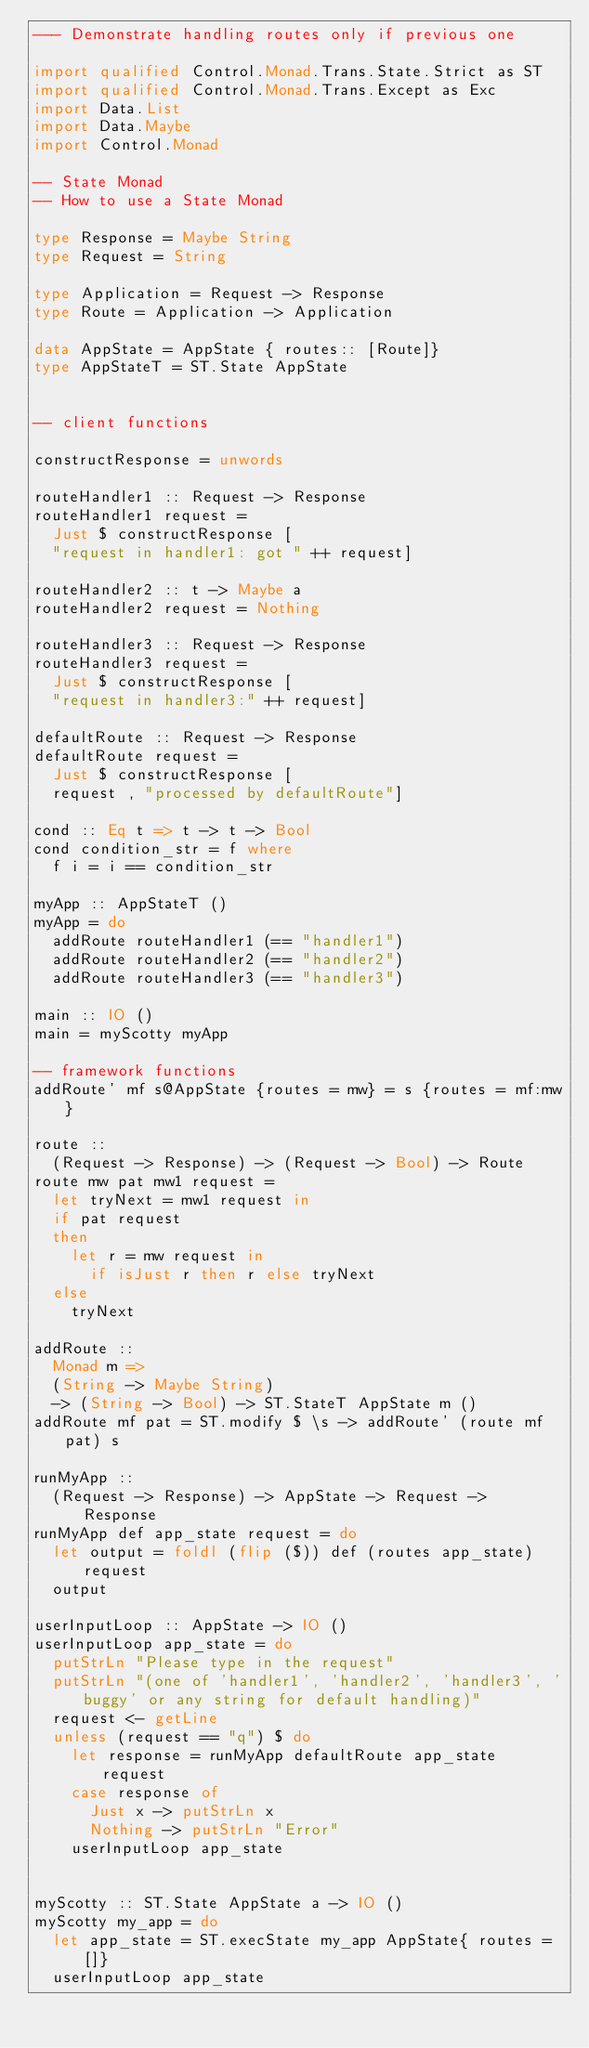<code> <loc_0><loc_0><loc_500><loc_500><_Haskell_>--- Demonstrate handling routes only if previous one

import qualified Control.Monad.Trans.State.Strict as ST
import qualified Control.Monad.Trans.Except as Exc
import Data.List
import Data.Maybe
import Control.Monad

-- State Monad
-- How to use a State Monad

type Response = Maybe String
type Request = String

type Application = Request -> Response
type Route = Application -> Application

data AppState = AppState { routes:: [Route]}
type AppStateT = ST.State AppState


-- client functions

constructResponse = unwords

routeHandler1 :: Request -> Response
routeHandler1 request =
  Just $ constructResponse [
  "request in handler1: got " ++ request]

routeHandler2 :: t -> Maybe a
routeHandler2 request = Nothing

routeHandler3 :: Request -> Response
routeHandler3 request =
  Just $ constructResponse [
  "request in handler3:" ++ request]

defaultRoute :: Request -> Response
defaultRoute request =
  Just $ constructResponse [
  request , "processed by defaultRoute"]

cond :: Eq t => t -> t -> Bool
cond condition_str = f where
  f i = i == condition_str

myApp :: AppStateT ()
myApp = do
  addRoute routeHandler1 (== "handler1")
  addRoute routeHandler2 (== "handler2")
  addRoute routeHandler3 (== "handler3")

main :: IO ()
main = myScotty myApp

-- framework functions
addRoute' mf s@AppState {routes = mw} = s {routes = mf:mw}

route ::
  (Request -> Response) -> (Request -> Bool) -> Route
route mw pat mw1 request =
  let tryNext = mw1 request in
  if pat request
  then
    let r = mw request in
      if isJust r then r else tryNext
  else
    tryNext

addRoute ::
  Monad m =>
  (String -> Maybe String)
  -> (String -> Bool) -> ST.StateT AppState m ()
addRoute mf pat = ST.modify $ \s -> addRoute' (route mf pat) s

runMyApp ::
  (Request -> Response) -> AppState -> Request -> Response
runMyApp def app_state request = do
  let output = foldl (flip ($)) def (routes app_state) request
  output

userInputLoop :: AppState -> IO ()
userInputLoop app_state = do
  putStrLn "Please type in the request"
  putStrLn "(one of 'handler1', 'handler2', 'handler3', 'buggy' or any string for default handling)"
  request <- getLine
  unless (request == "q") $ do
    let response = runMyApp defaultRoute app_state request
    case response of
      Just x -> putStrLn x
      Nothing -> putStrLn "Error"
    userInputLoop app_state


myScotty :: ST.State AppState a -> IO ()
myScotty my_app = do
  let app_state = ST.execState my_app AppState{ routes = []}
  userInputLoop app_state</code> 